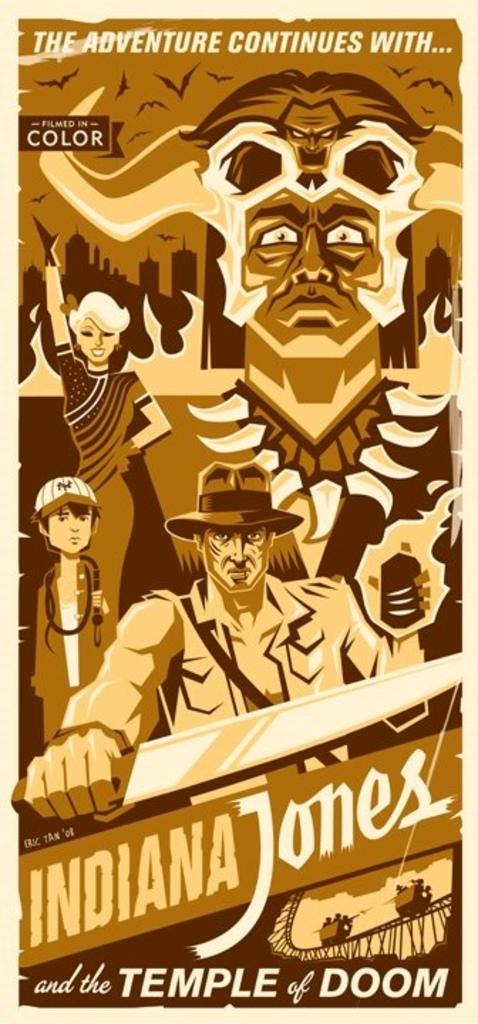What movie is the poster advertising?
Your response must be concise. Indiana jones. Is this movie in color or in black-and-white?
Make the answer very short. Color. 